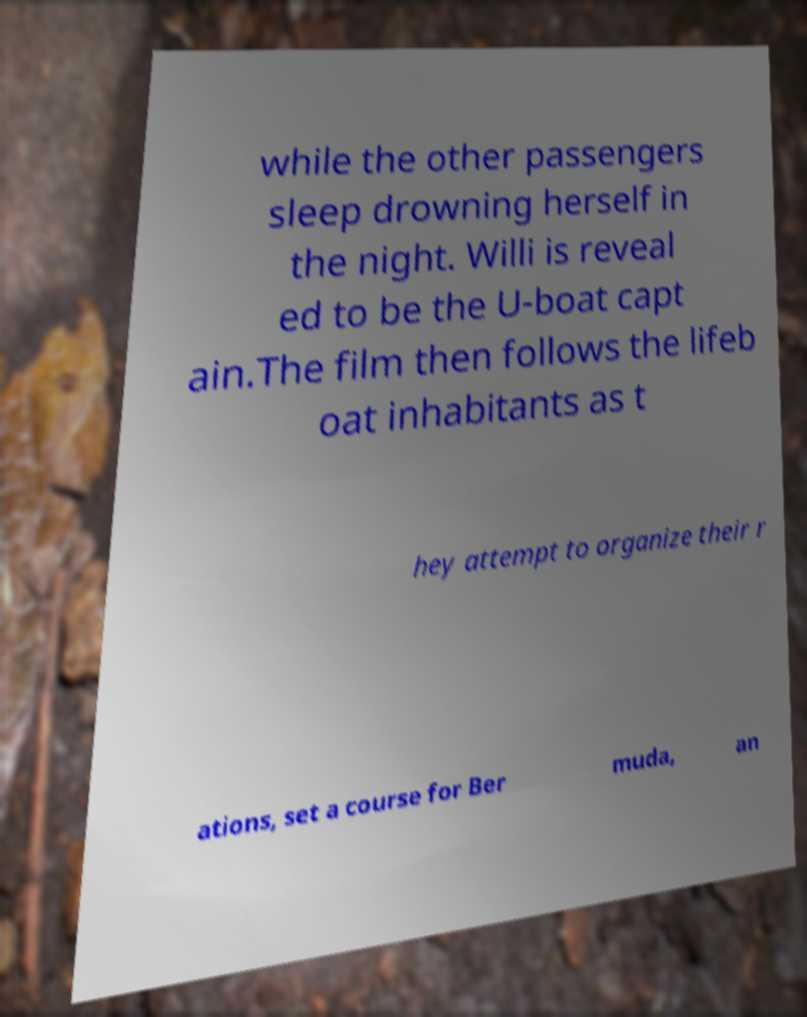I need the written content from this picture converted into text. Can you do that? while the other passengers sleep drowning herself in the night. Willi is reveal ed to be the U-boat capt ain.The film then follows the lifeb oat inhabitants as t hey attempt to organize their r ations, set a course for Ber muda, an 